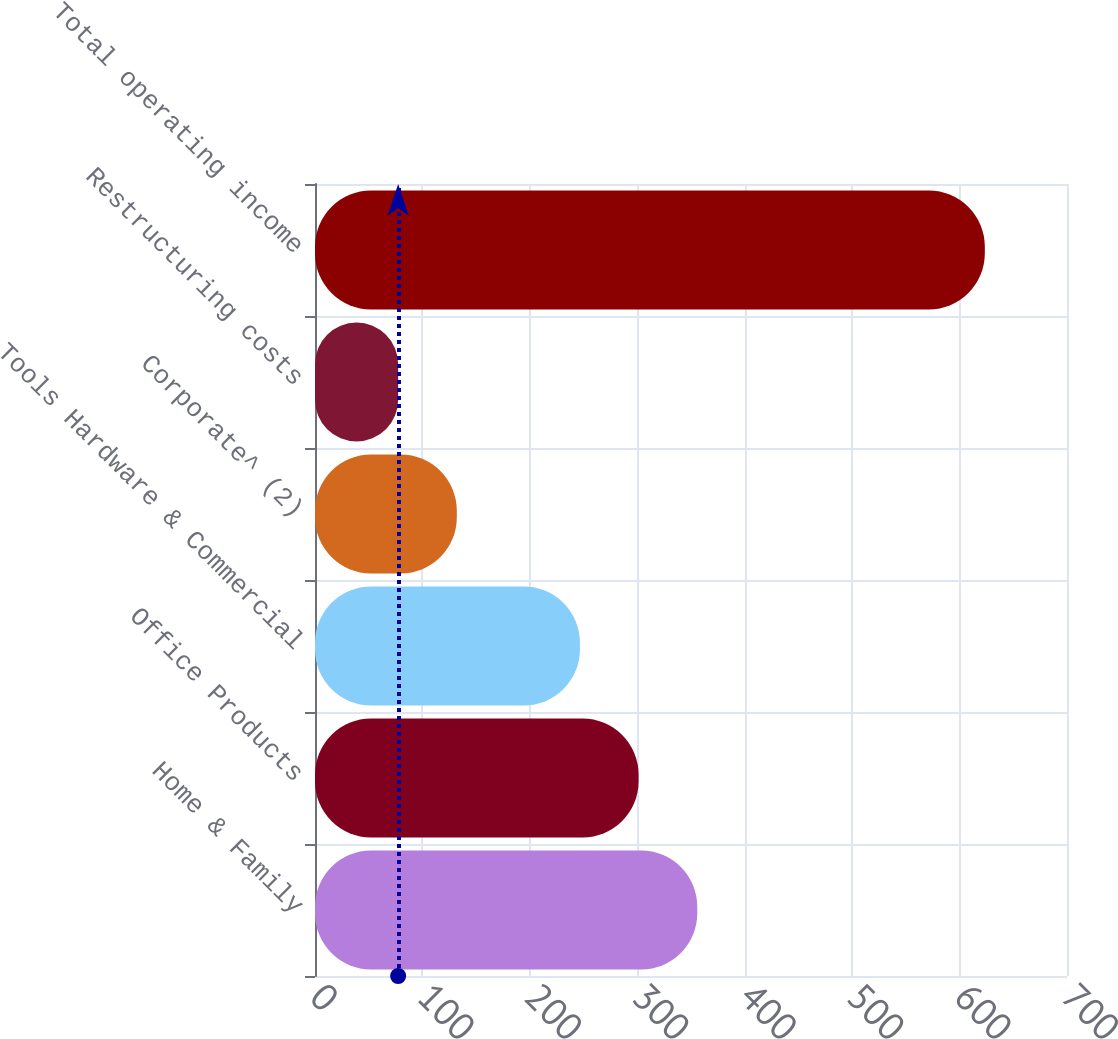Convert chart to OTSL. <chart><loc_0><loc_0><loc_500><loc_500><bar_chart><fcel>Home & Family<fcel>Office Products<fcel>Tools Hardware & Commercial<fcel>Corporate^ (2)<fcel>Restructuring costs<fcel>Total operating income<nl><fcel>355.82<fcel>301.21<fcel>246.6<fcel>132.01<fcel>77.4<fcel>623.5<nl></chart> 